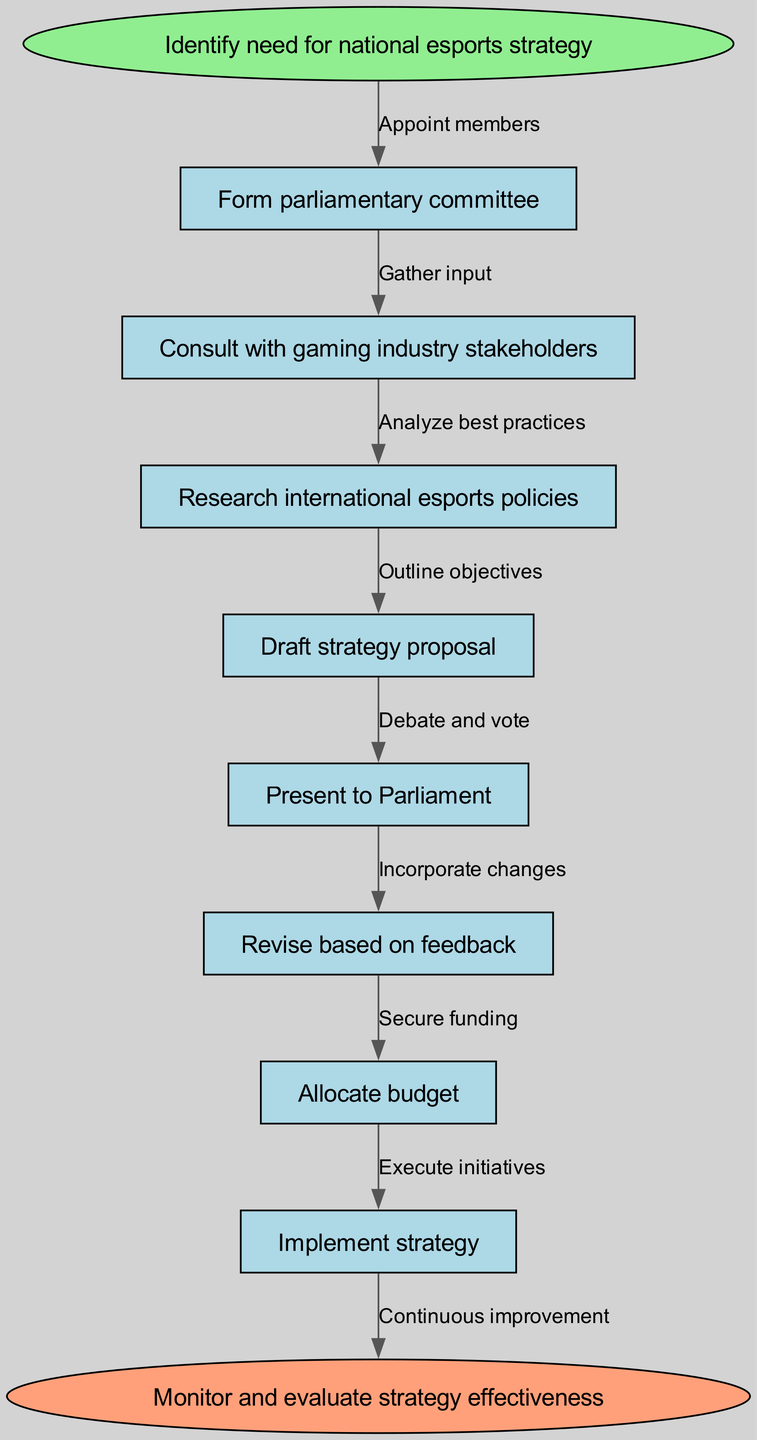What is the starting point of the strategy development process? The starting point is indicated by the first node, which is "Identify need for national esports strategy."
Answer: Identify need for national esports strategy How many main nodes are there in the diagram? There are eight main nodes including the start and end nodes. The nodes are: "Identify need for national esports strategy", "Form parliamentary committee", "Consult with gaming industry stakeholders", "Research international esports policies", "Draft strategy proposal", "Present to Parliament", "Revise based on feedback", "Allocate budget", "Implement strategy", and "Monitor and evaluate strategy effectiveness."
Answer: Eight What is the last phase in the strategy development process? The last phase is reflected in the end node, which contains the statement "Monitor and evaluate strategy effectiveness."
Answer: Monitor and evaluate strategy effectiveness Which node follows the "Research international esports policies"? The node that follows "Research international esports policies" is "Draft strategy proposal." This is connected by the edge labeled "Outline objectives."
Answer: Draft strategy proposal What action is taken after presenting the strategy proposal to Parliament? After presenting the strategy proposal to Parliament, the next action is to "Revise based on feedback." This is indicated by the flow from the "Present to Parliament" node to the "Revise based on feedback" node.
Answer: Revise based on feedback What is the relationship between "Implement strategy" and "Allocate budget"? The relationship is that "Allocate budget" occurs before "Implement strategy". The process flows from "Allocate budget" to "Implement strategy," indicating that funding must be secured prior to execution.
Answer: Allocate budget -> Implement strategy What edge connects the "Consult with gaming industry stakeholders" node to its preceding node? The edge that connects it is labeled "Gather input," indicating that input is gathered from stakeholders prior to making further decisions.
Answer: Gather input Which phase involves continuous improvement? Continuous improvement is associated with the end node "Monitor and evaluate strategy effectiveness," as it signifies an ongoing process of assessing and adapting the strategy.
Answer: Monitor and evaluate strategy effectiveness 